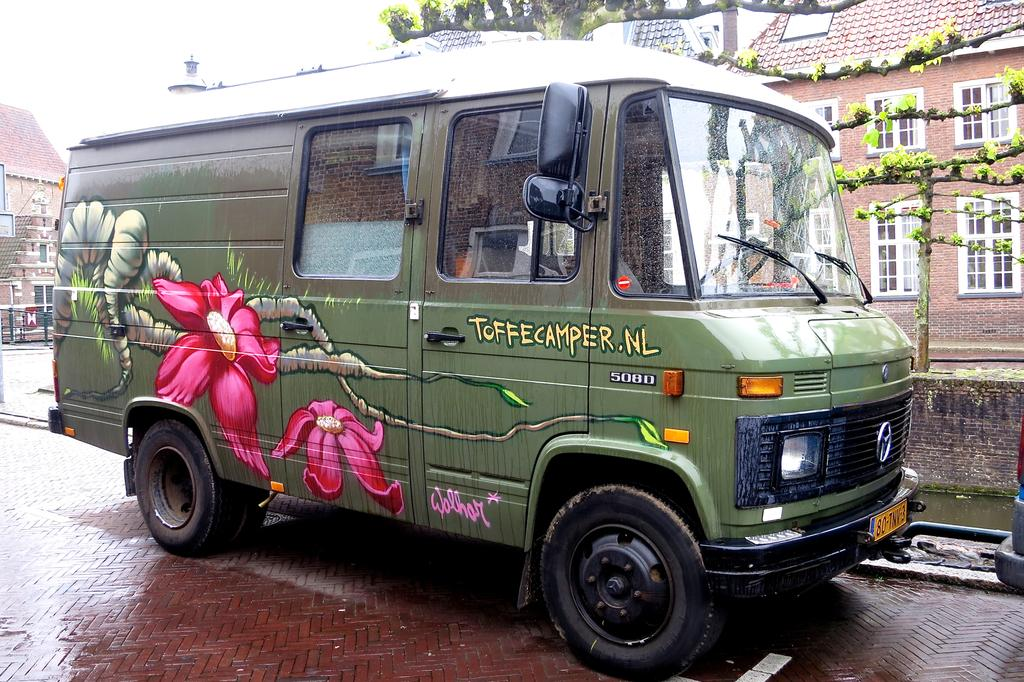<image>
Write a terse but informative summary of the picture. parked green 5080 bmw van with flowers painted on the side and toffecamper.nl 